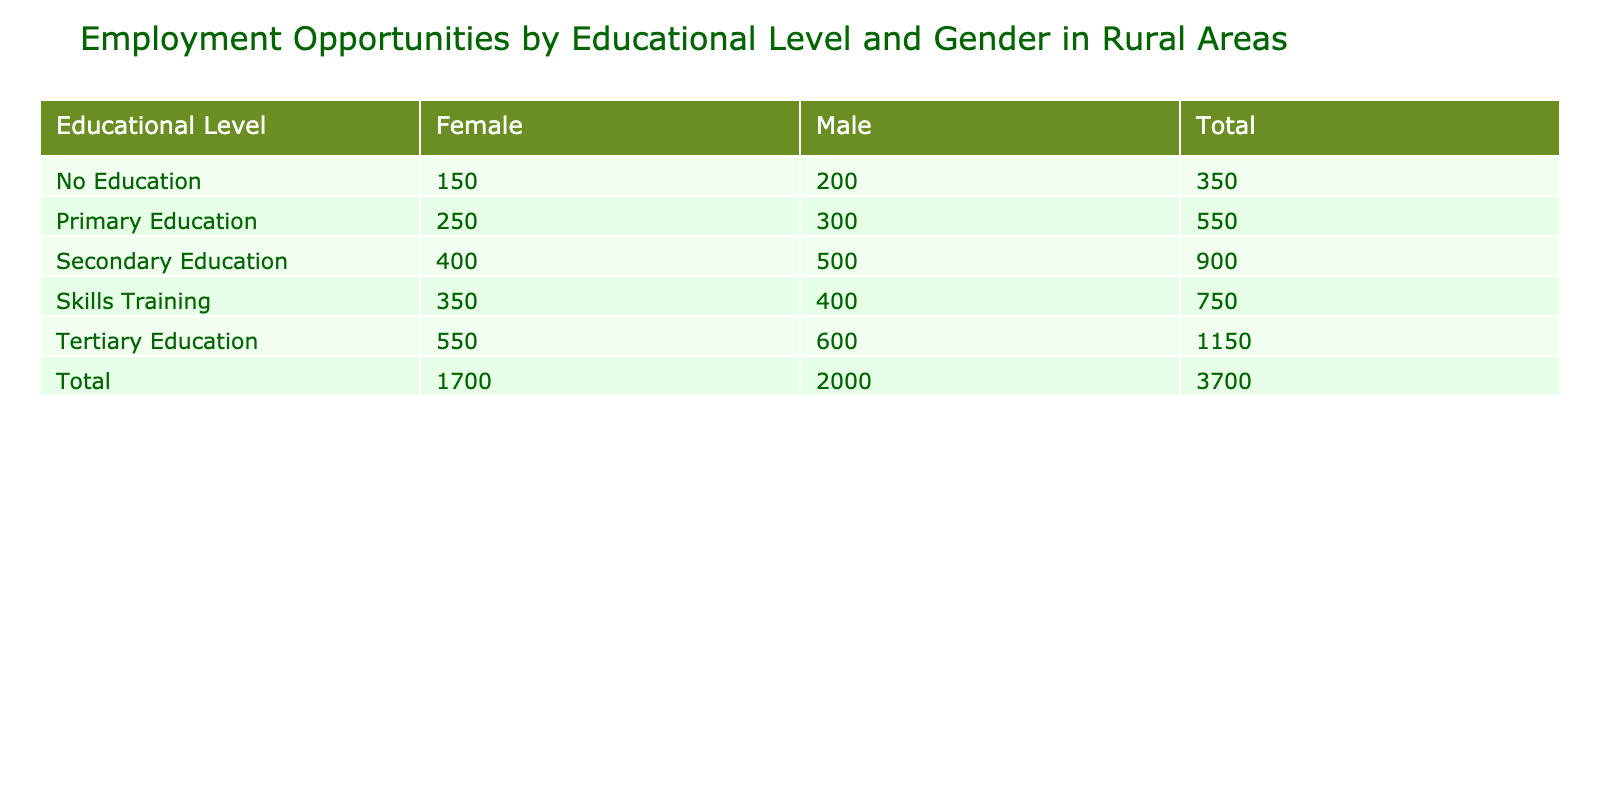What is the total number of employment opportunities for males with tertiary education? From the table, we can locate the row for tertiary education under the male gender. The value listed there is 600, which represents the total number of employment opportunities for males with tertiary education.
Answer: 600 How many employment opportunities are available for females with no education? Referring to the row for no education under the female gender, the value recorded is 150. This is the number of employment opportunities for females without any formal education.
Answer: 150 What is the difference in employment opportunities between males and females with primary education? To find the difference, we look at the primary education row for both genders. The opportunities for males is 300 and for females, it is 250. The difference is calculated as 300 - 250 = 50.
Answer: 50 Is there a higher number of employment opportunities for males with secondary education compared to all females combined across all educational levels? First, we check the value for males with secondary education, which is 500. Next, we sum the values for females across all educational levels: 150 (no education) + 250 (primary) + 400 (secondary) + 550 (tertiary) + 350 (skills training) = 1900. Since 500 is less than 1900, the statement is false.
Answer: No What is the average number of employment opportunities for females across all educational levels? We take the values for females from all levels: 150 (no education) + 250 (primary) + 400 (secondary) + 550 (tertiary) + 350 (skills training) = 1900. There are 5 data points (one for each educational level), so to find the average, we divide total opportunities (1900) by 5: 1900 / 5 = 380.
Answer: 380 How many total employment opportunities exist for skills training across both genders? We find the row for skills training and add the values for both genders. The number of opportunities for males is 400 and for females is 350, so the total is 400 + 350 = 750.
Answer: 750 Which gender has the highest employment opportunities at the secondary education level? By reviewing the secondary education row, we see that males have 500 opportunities, while females have 400. Since 500 is greater than 400, males have the highest opportunities at the secondary education level.
Answer: Male What is the combined total employment opportunities for both genders at the tertiary education level? We check the tertiary education row: males have 600 and females have 550. The combined total is 600 + 550 = 1150.
Answer: 1150 